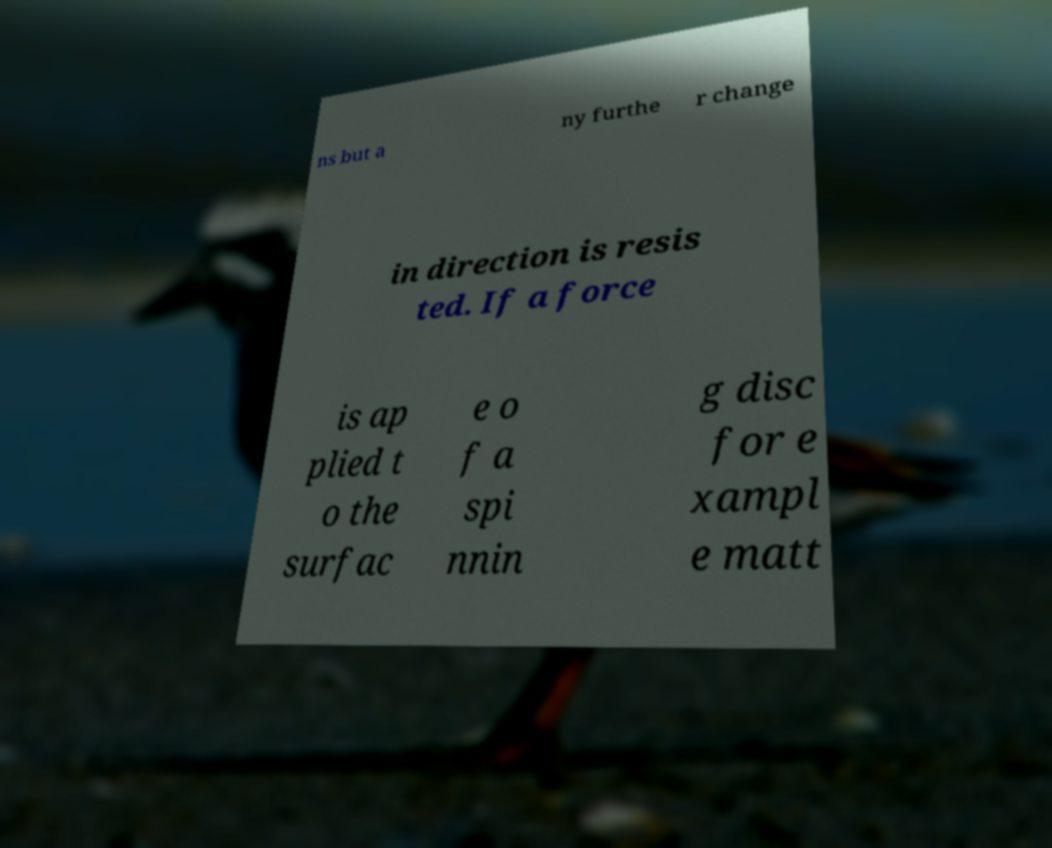For documentation purposes, I need the text within this image transcribed. Could you provide that? ns but a ny furthe r change in direction is resis ted. If a force is ap plied t o the surfac e o f a spi nnin g disc for e xampl e matt 